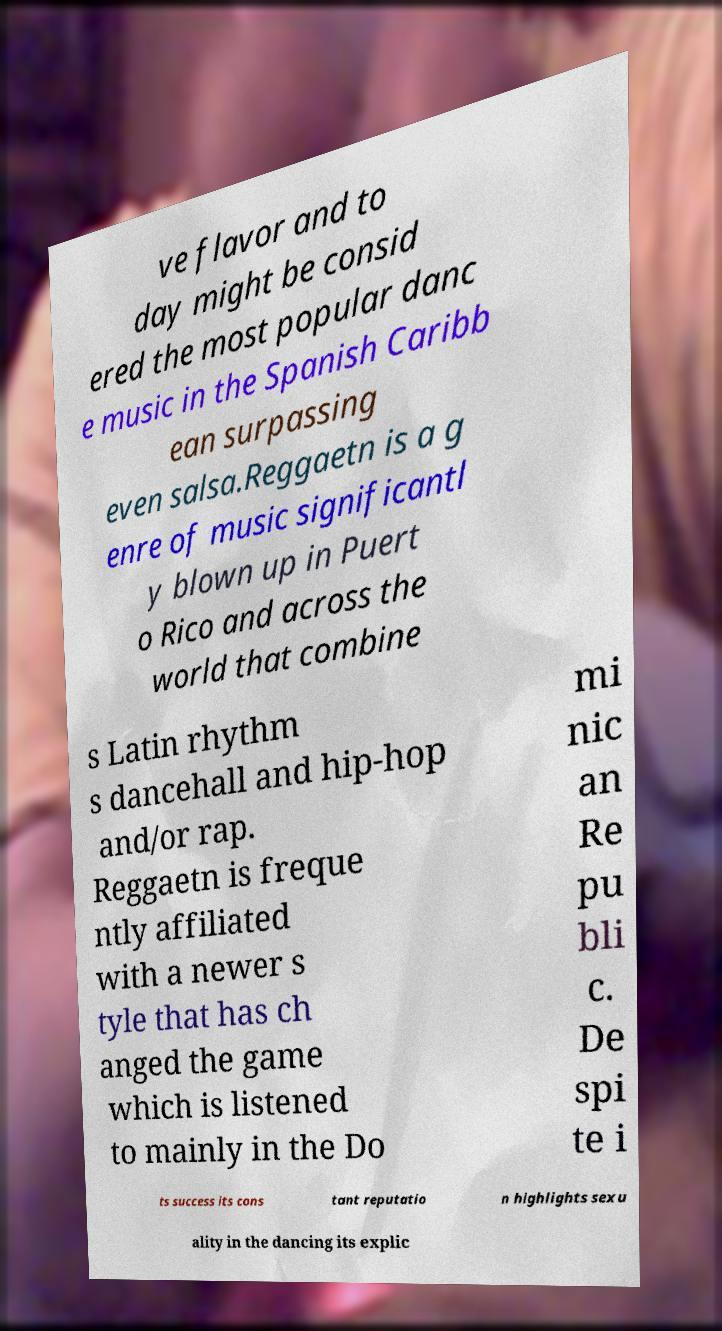For documentation purposes, I need the text within this image transcribed. Could you provide that? ve flavor and to day might be consid ered the most popular danc e music in the Spanish Caribb ean surpassing even salsa.Reggaetn is a g enre of music significantl y blown up in Puert o Rico and across the world that combine s Latin rhythm s dancehall and hip-hop and/or rap. Reggaetn is freque ntly affiliated with a newer s tyle that has ch anged the game which is listened to mainly in the Do mi nic an Re pu bli c. De spi te i ts success its cons tant reputatio n highlights sexu ality in the dancing its explic 